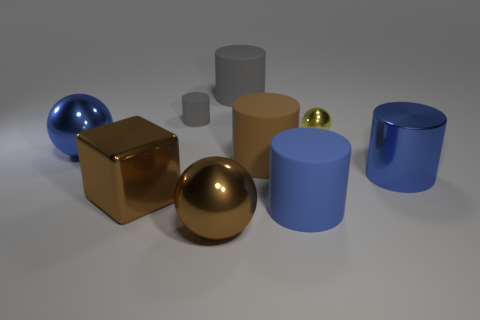Subtract all large brown balls. How many balls are left? 2 Subtract all yellow spheres. How many spheres are left? 2 Subtract 1 cubes. How many cubes are left? 0 Add 1 big brown metallic things. How many objects exist? 10 Subtract all balls. How many objects are left? 6 Subtract all brown cylinders. How many brown spheres are left? 1 Subtract all gray balls. Subtract all purple cylinders. How many balls are left? 3 Subtract all tiny brown cylinders. Subtract all blue metal objects. How many objects are left? 7 Add 7 gray rubber cylinders. How many gray rubber cylinders are left? 9 Add 8 large balls. How many large balls exist? 10 